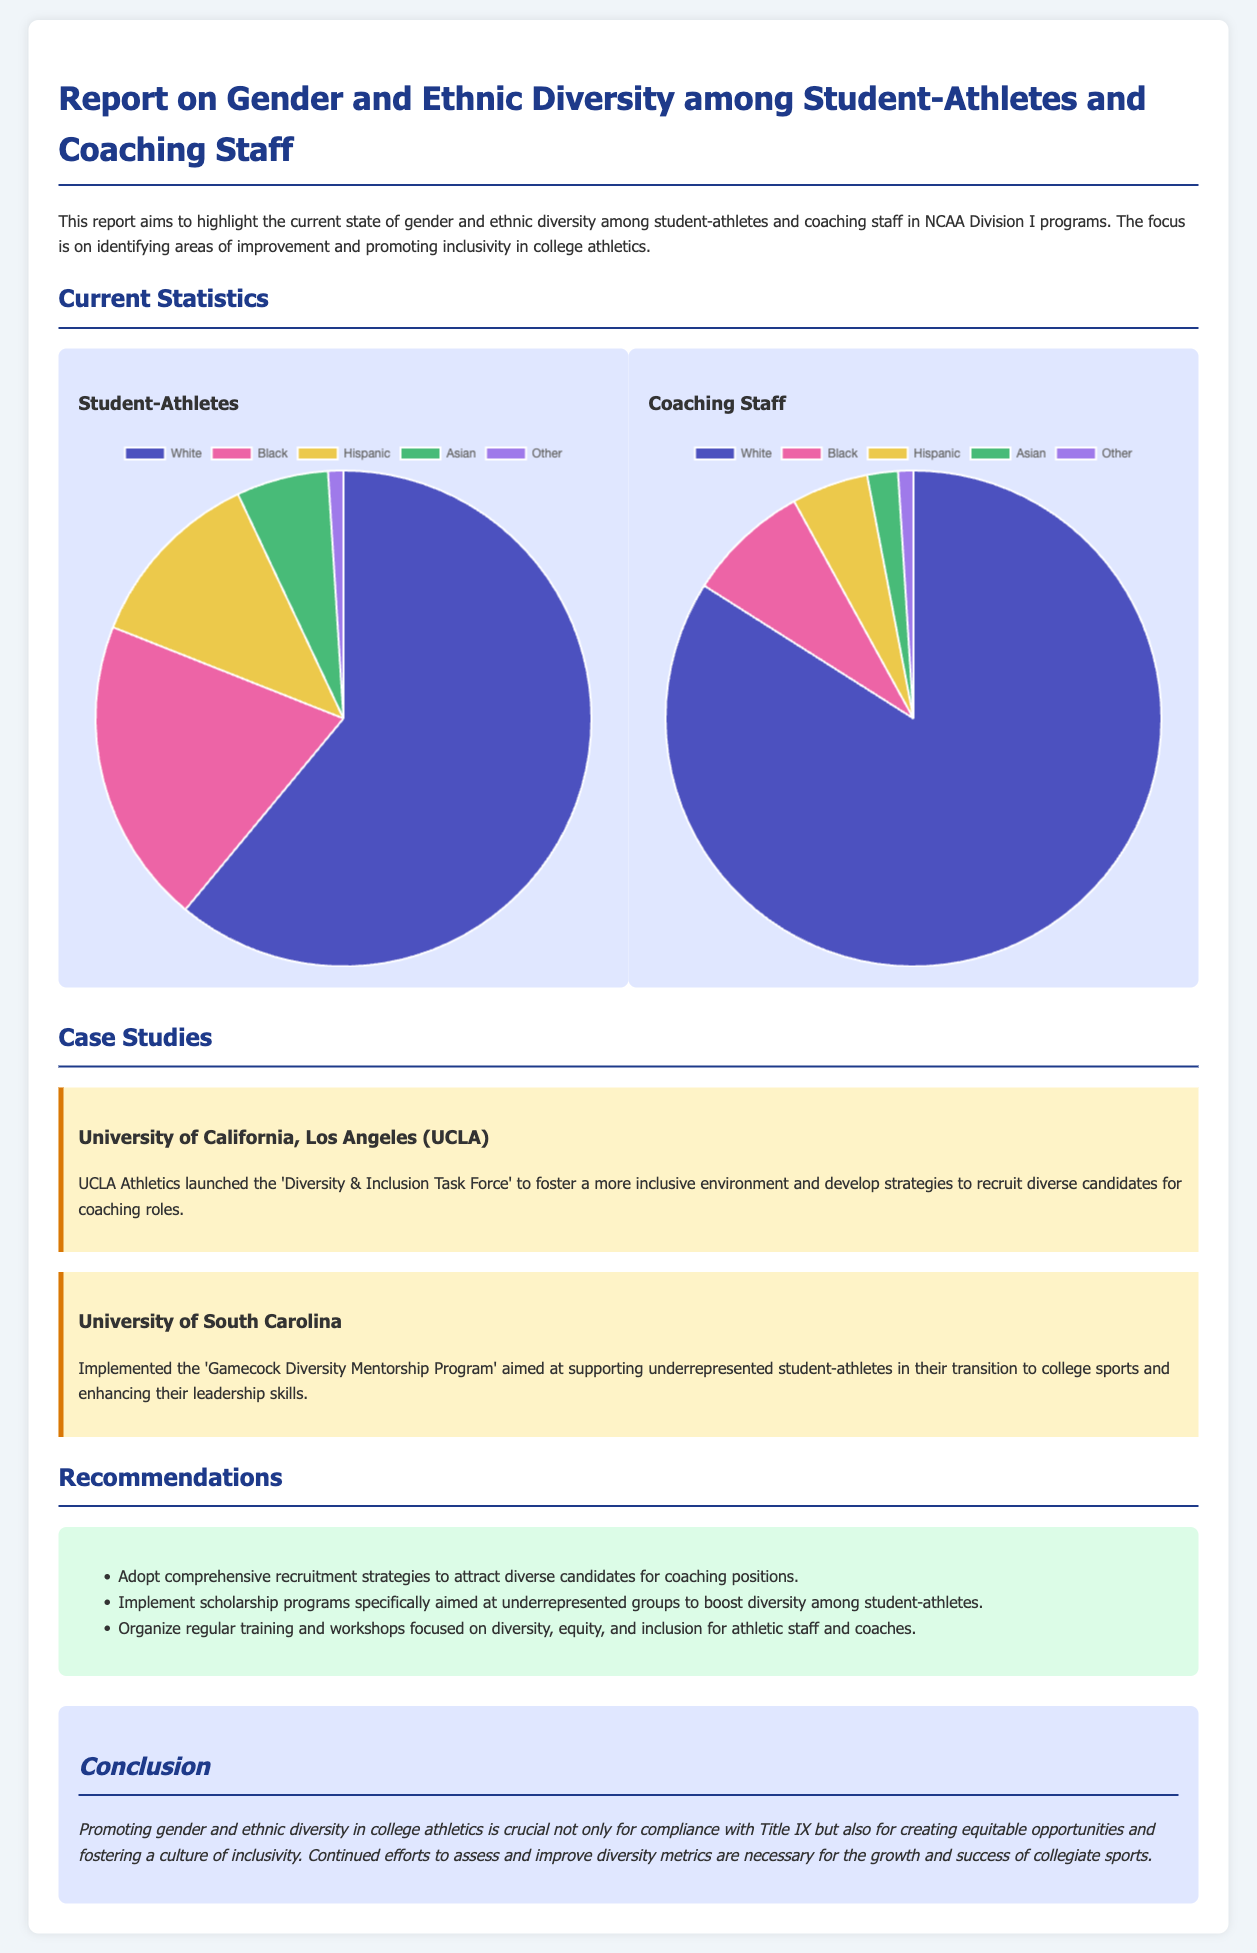What is the primary focus of the report? The report aims to highlight the current state of gender and ethnic diversity among student-athletes and coaching staff in NCAA Division I programs.
Answer: Gender and ethnic diversity What percentage of student-athletes are Black? The document provides a pie chart showing the ethnic diversity among student-athletes, listing Black student-athletes at 20%.
Answer: 20% What is the percentage of Hispanic coaching staff? The coaching staff diversity chart shows that Hispanic coaching staff account for 5%.
Answer: 5% Which university launched the 'Diversity & Inclusion Task Force'? The case study section mentions that the University of California, Los Angeles (UCLA) launched this initiative.
Answer: UCLA What is one of the recommendations given in the report? The report lists several recommendations, such as adopting comprehensive recruitment strategies to attract diverse candidates for coaching positions.
Answer: Adopt comprehensive recruitment strategies What is the total percentage of White student-athletes? According to the ethnic diversity chart, White student-athletes make up 61% of the total.
Answer: 61% How many total ethnic categories are presented in the student-athlete chart? The chart includes five ethnic categories: White, Black, Hispanic, Asian, and Other.
Answer: Five What is the primary legal compliance mentioned in the conclusion? The conclusion states that promoting gender and ethnic diversity is crucial for compliance with Title IX.
Answer: Title IX 